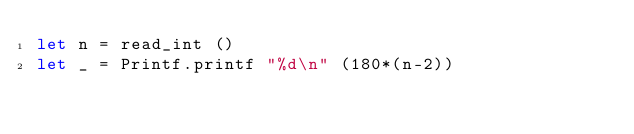Convert code to text. <code><loc_0><loc_0><loc_500><loc_500><_OCaml_>let n = read_int ()
let _ = Printf.printf "%d\n" (180*(n-2))</code> 